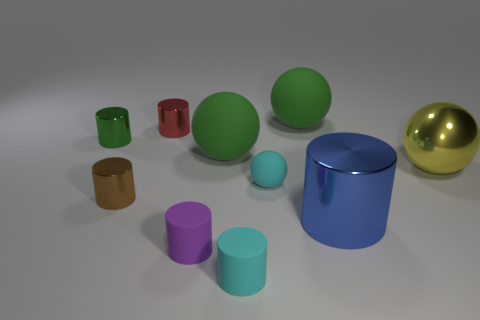What is the tiny object that is both in front of the red thing and behind the yellow ball made of?
Make the answer very short. Metal. Is the size of the brown shiny cylinder the same as the cyan object behind the small brown cylinder?
Offer a terse response. Yes. Are there any big gray matte spheres?
Make the answer very short. No. There is a brown object that is the same shape as the tiny red metallic object; what is its material?
Give a very brief answer. Metal. What is the size of the cylinder that is right of the green ball behind the tiny metal cylinder left of the small brown object?
Provide a short and direct response. Large. Are there any yellow metal things to the left of the red object?
Your answer should be compact. No. What is the size of the blue cylinder that is the same material as the red cylinder?
Provide a short and direct response. Large. How many big yellow metallic objects have the same shape as the red thing?
Provide a succinct answer. 0. Is the material of the tiny purple thing the same as the tiny cyan object behind the blue metal cylinder?
Offer a terse response. Yes. Is the number of small metal things right of the green shiny object greater than the number of small rubber balls?
Offer a very short reply. Yes. 